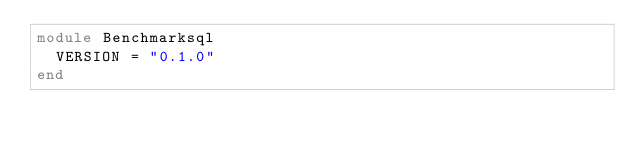Convert code to text. <code><loc_0><loc_0><loc_500><loc_500><_Ruby_>module Benchmarksql
  VERSION = "0.1.0"
end
</code> 